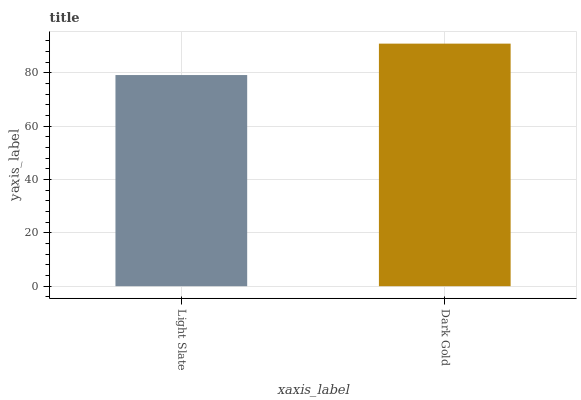Is Light Slate the minimum?
Answer yes or no. Yes. Is Dark Gold the maximum?
Answer yes or no. Yes. Is Dark Gold the minimum?
Answer yes or no. No. Is Dark Gold greater than Light Slate?
Answer yes or no. Yes. Is Light Slate less than Dark Gold?
Answer yes or no. Yes. Is Light Slate greater than Dark Gold?
Answer yes or no. No. Is Dark Gold less than Light Slate?
Answer yes or no. No. Is Dark Gold the high median?
Answer yes or no. Yes. Is Light Slate the low median?
Answer yes or no. Yes. Is Light Slate the high median?
Answer yes or no. No. Is Dark Gold the low median?
Answer yes or no. No. 